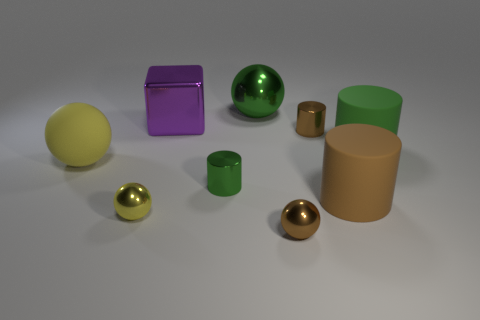How would you categorize the objects in terms of shapes? The objects can be categorized into spheres, cubes, and cylinders. There's a diversity of sizes, suggesting a deliberate arrangement for visual contrast.  Considering their different materials, what could be the purpose of these objects? It's difficult to determine their exact purpose without context, but they could be part of a display or setup for a study in material properties, reflections, and geometry. 